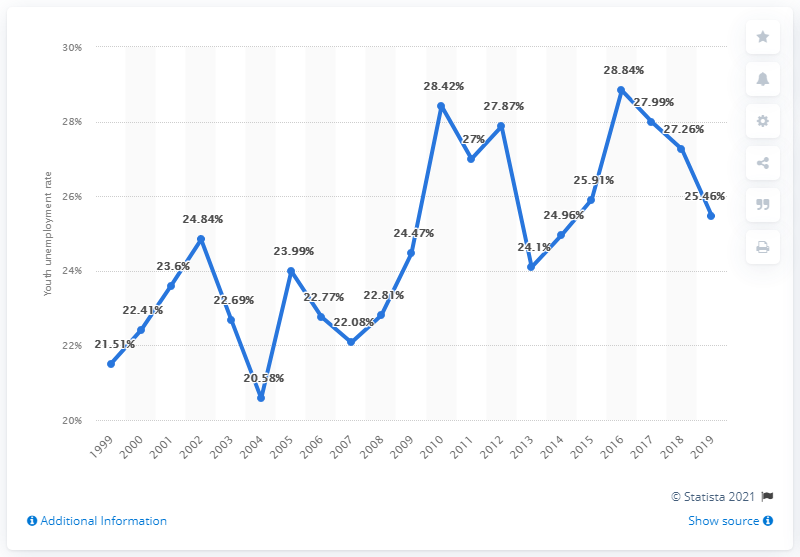List a handful of essential elements in this visual. In 2019, the youth unemployment rate in Iran was 25.46%. 